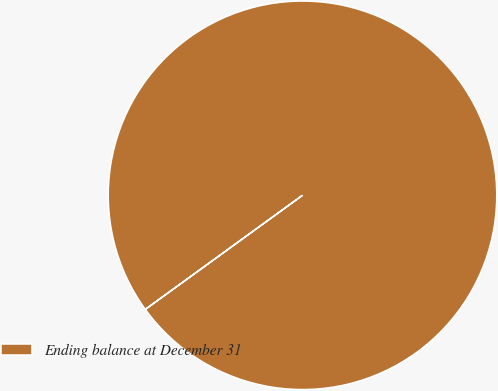<chart> <loc_0><loc_0><loc_500><loc_500><pie_chart><fcel>Ending balance at December 31<nl><fcel>100.0%<nl></chart> 